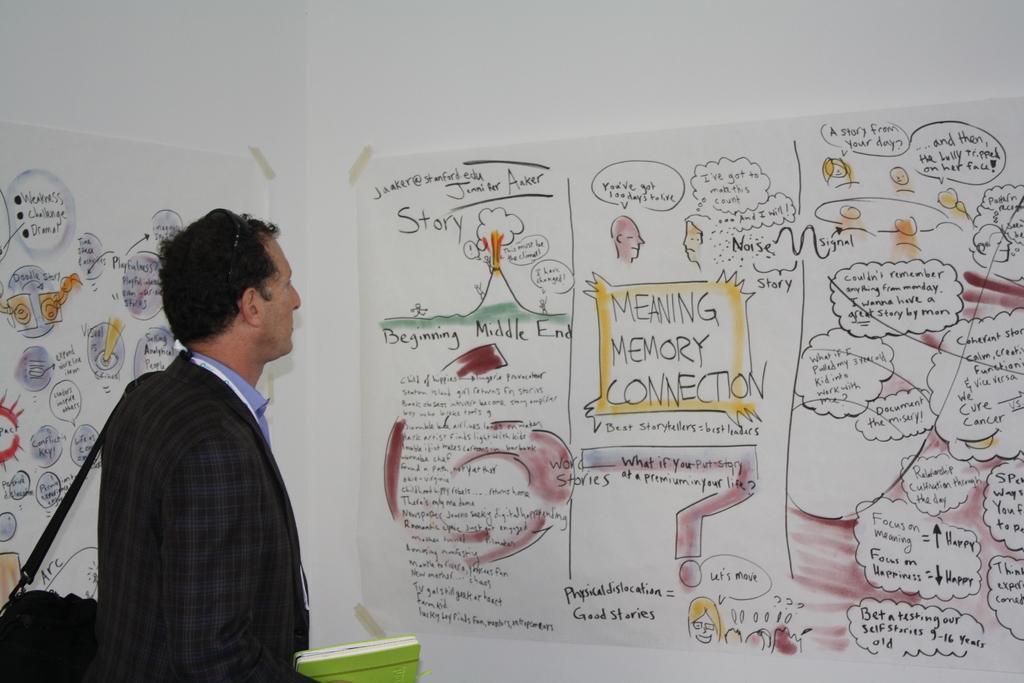<image>
Give a short and clear explanation of the subsequent image. A man gazes at a storyboard about stories there is emphasized text like Meaning, Memory and Connection plus illustrations 